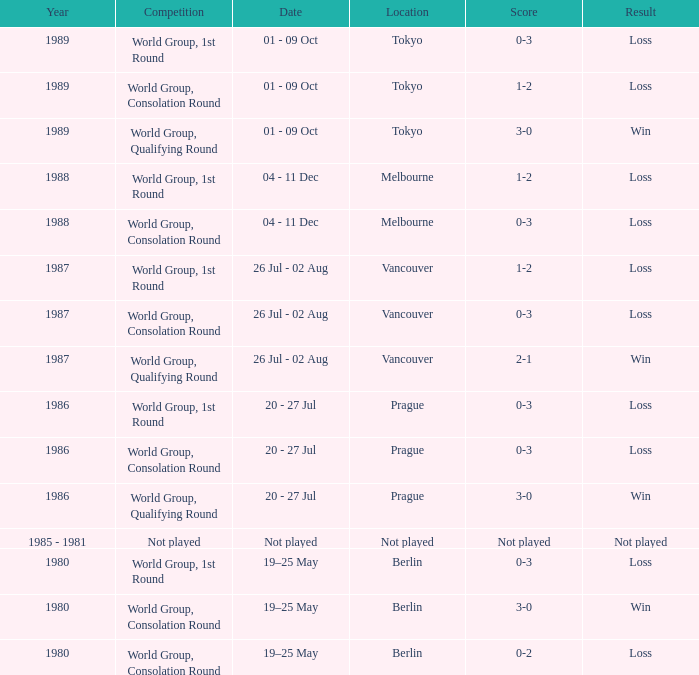What is the rivalry in tokyo that led to a lost result? World Group, 1st Round, World Group, Consolation Round. 